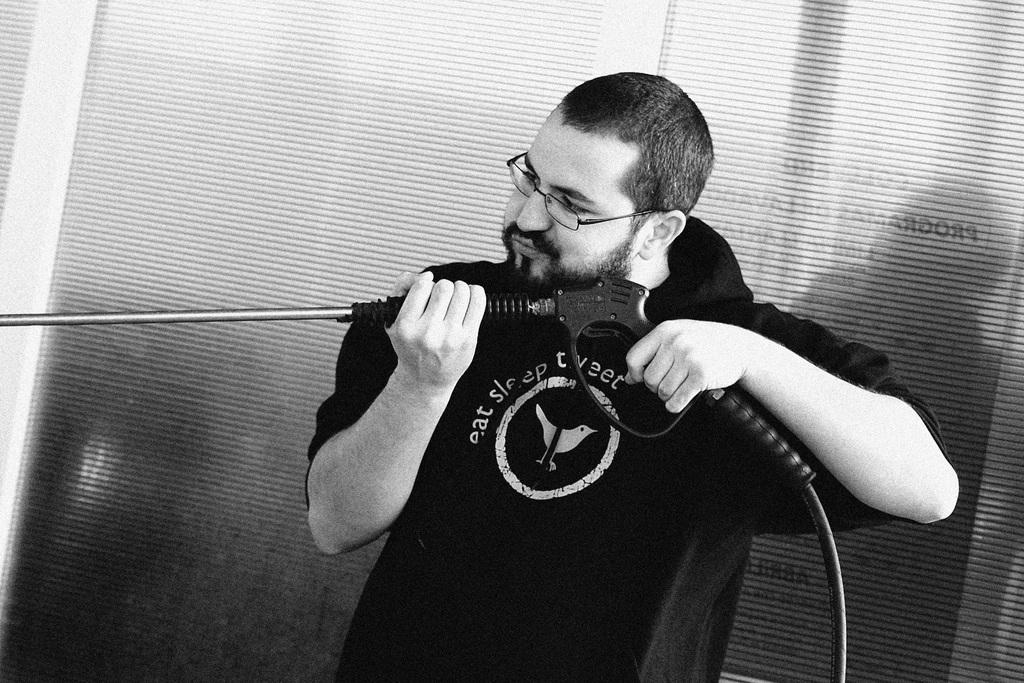What is the man in the image doing? The man is standing in the image. What is the man holding in the image? The man is holding an object. What can be seen in the background of the image? There are blinds in the background of the image. What type of society is depicted in the background of the image? There is no society depicted in the image; it only features the man, the object he is holding, and the blinds in the background. 